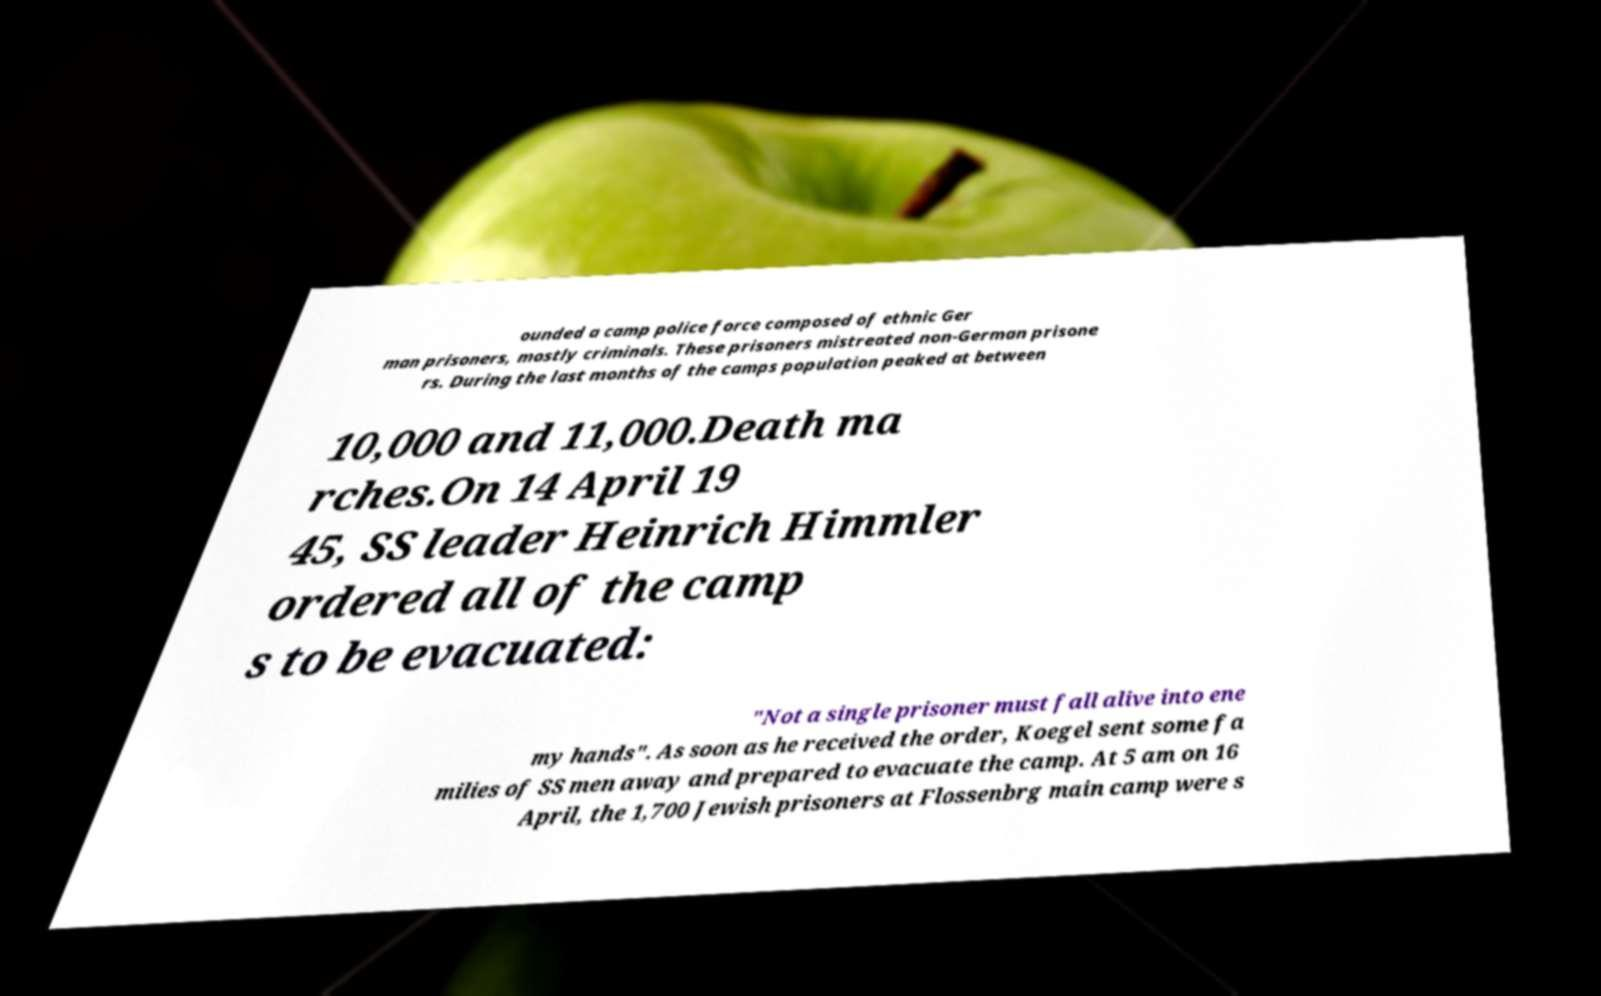Could you assist in decoding the text presented in this image and type it out clearly? ounded a camp police force composed of ethnic Ger man prisoners, mostly criminals. These prisoners mistreated non-German prisone rs. During the last months of the camps population peaked at between 10,000 and 11,000.Death ma rches.On 14 April 19 45, SS leader Heinrich Himmler ordered all of the camp s to be evacuated: "Not a single prisoner must fall alive into ene my hands". As soon as he received the order, Koegel sent some fa milies of SS men away and prepared to evacuate the camp. At 5 am on 16 April, the 1,700 Jewish prisoners at Flossenbrg main camp were s 